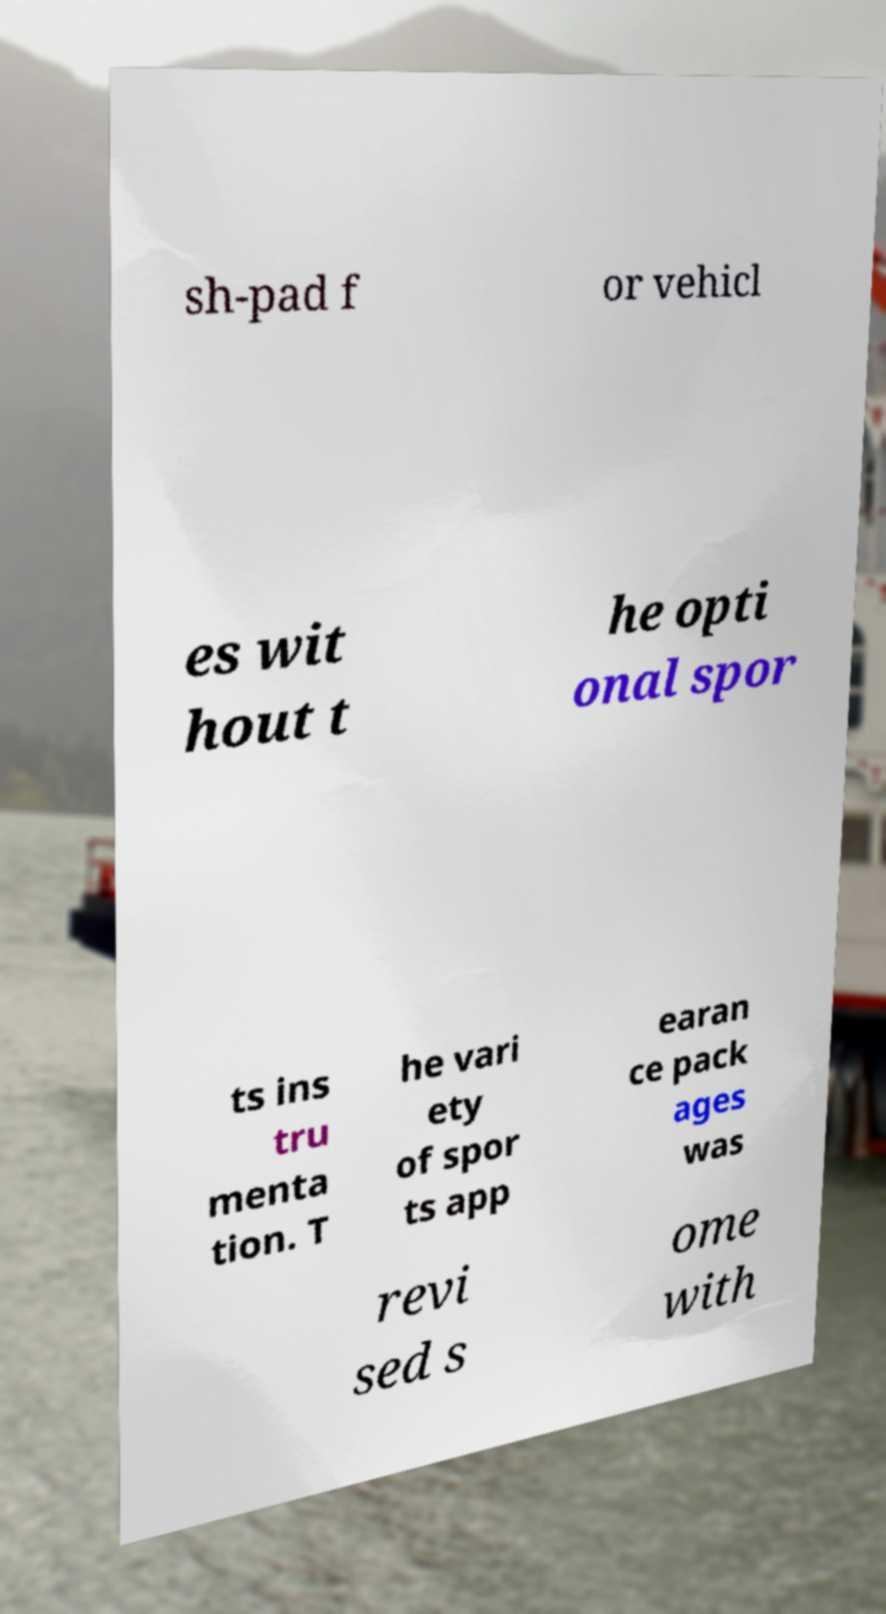What messages or text are displayed in this image? I need them in a readable, typed format. sh-pad f or vehicl es wit hout t he opti onal spor ts ins tru menta tion. T he vari ety of spor ts app earan ce pack ages was revi sed s ome with 